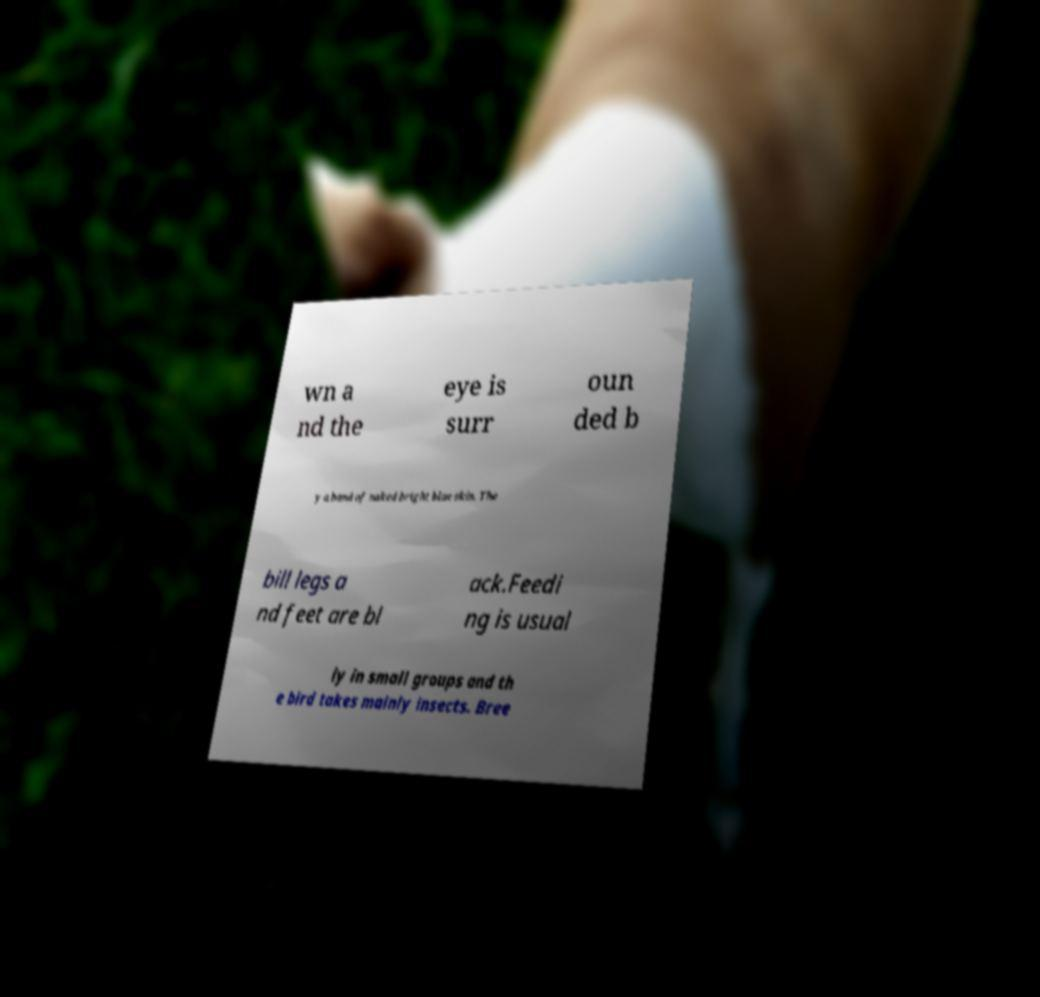For documentation purposes, I need the text within this image transcribed. Could you provide that? wn a nd the eye is surr oun ded b y a band of naked bright blue skin. The bill legs a nd feet are bl ack.Feedi ng is usual ly in small groups and th e bird takes mainly insects. Bree 